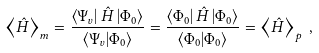<formula> <loc_0><loc_0><loc_500><loc_500>\left \langle \hat { H } \right \rangle _ { m } = \frac { \left \langle { \Psi _ { v } } \right | \hat { H } \left | { \Phi _ { 0 } } \right \rangle } { \left \langle { \Psi _ { v } } | { \Phi _ { 0 } } \right \rangle } = \frac { \left \langle { \Phi _ { 0 } } \right | \hat { H } \left | { \Phi _ { 0 } } \right \rangle } { \left \langle { \Phi _ { 0 } } | { \Phi _ { 0 } } \right \rangle } = \left \langle \hat { H } \right \rangle _ { p } \, ,</formula> 